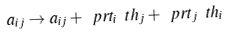Convert formula to latex. <formula><loc_0><loc_0><loc_500><loc_500>a _ { i j } \to a _ { i j } + \ p r t _ { i } \ t h _ { j } + \ p r t _ { j } \ t h _ { i }</formula> 